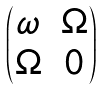<formula> <loc_0><loc_0><loc_500><loc_500>\begin{pmatrix} \omega & \Omega \\ \Omega & 0 \end{pmatrix}</formula> 